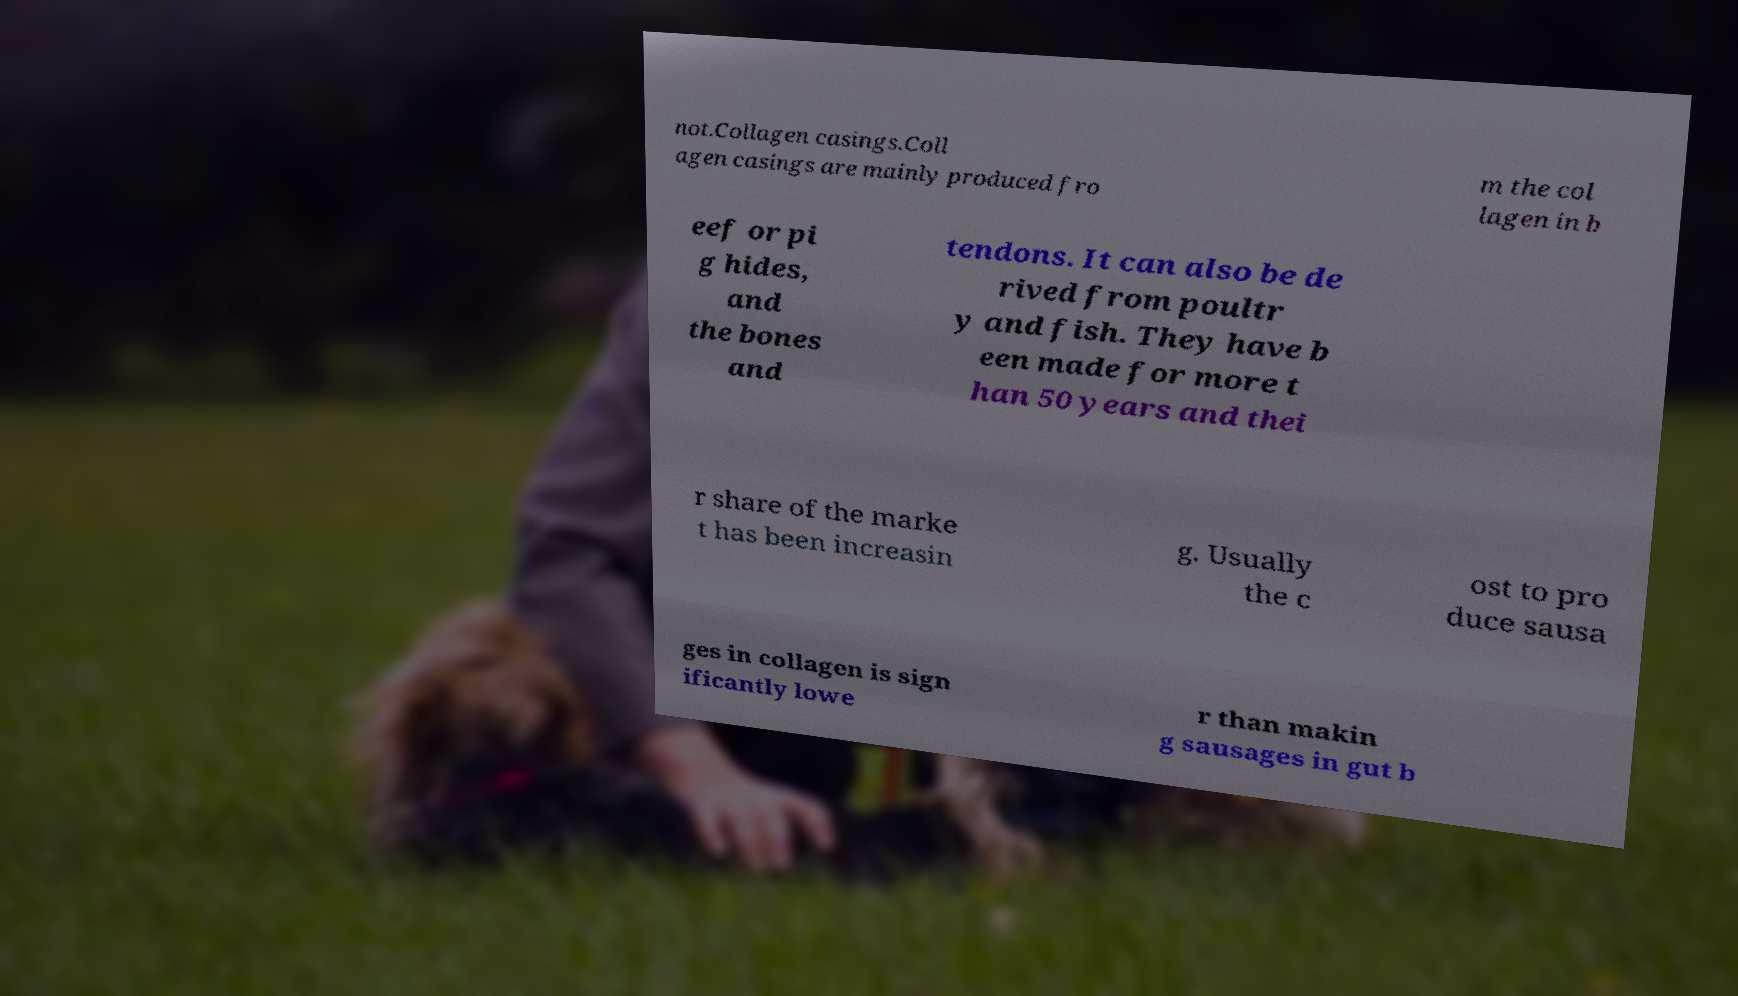There's text embedded in this image that I need extracted. Can you transcribe it verbatim? not.Collagen casings.Coll agen casings are mainly produced fro m the col lagen in b eef or pi g hides, and the bones and tendons. It can also be de rived from poultr y and fish. They have b een made for more t han 50 years and thei r share of the marke t has been increasin g. Usually the c ost to pro duce sausa ges in collagen is sign ificantly lowe r than makin g sausages in gut b 